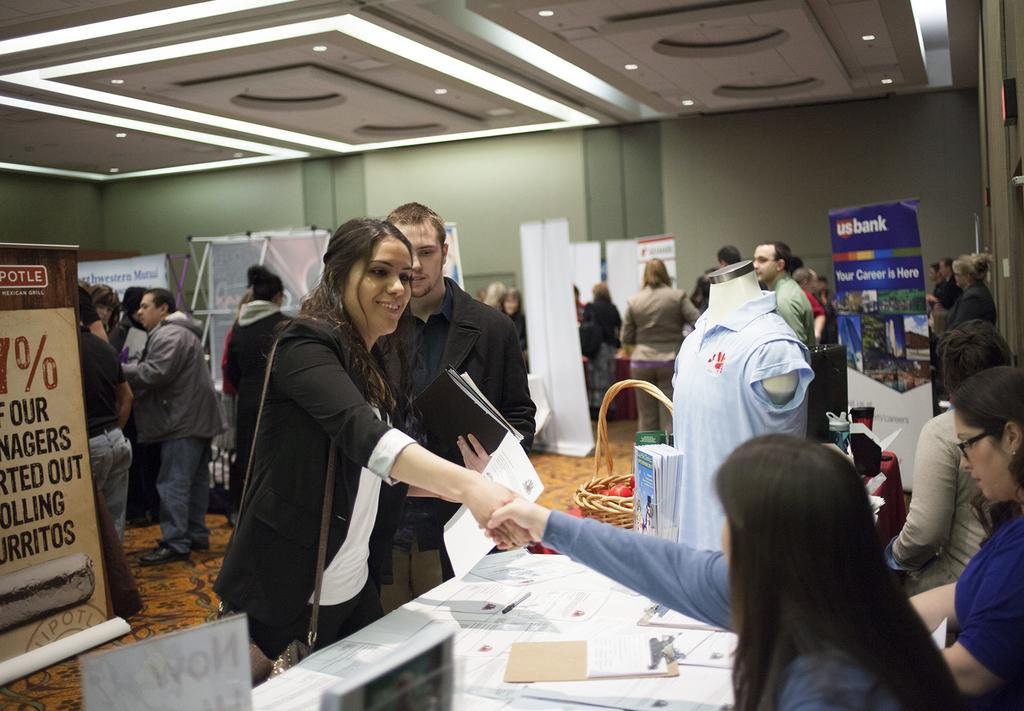Provide a one-sentence caption for the provided image. A US Bank sign hangs in the corner at this event. 